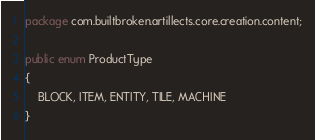Convert code to text. <code><loc_0><loc_0><loc_500><loc_500><_Java_>package com.builtbroken.artillects.core.creation.content;

public enum ProductType
{
    BLOCK, ITEM, ENTITY, TILE, MACHINE
}
</code> 